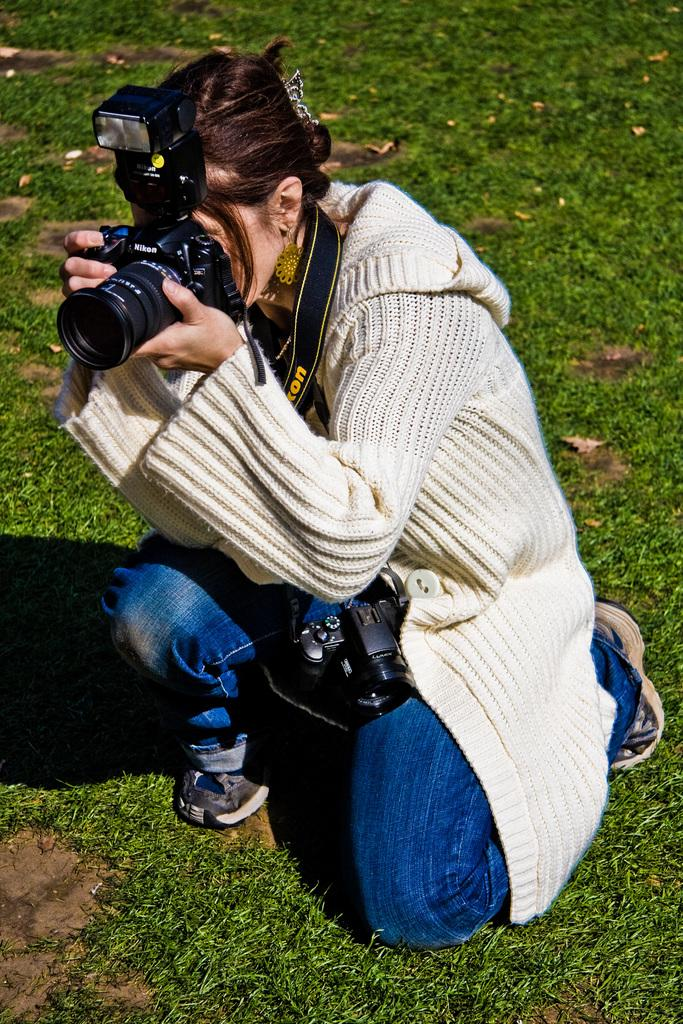Who is the main subject in the image? There is a woman in the image. What is the woman wearing? The woman is wearing a white sweater. What is the woman holding in the image? The woman is holding a camera. What is the woman doing with the camera? The woman is taking a snap. What type of environment is visible in the image? There is grass in the image. What type of glass can be seen in the woman's hand in the image? There is no glass present in the woman's hand in the image; she is holding a camera. What type of vessel is the woman using to take the snap in the image? The woman is not using a vessel to take the snap; she is using a camera. 